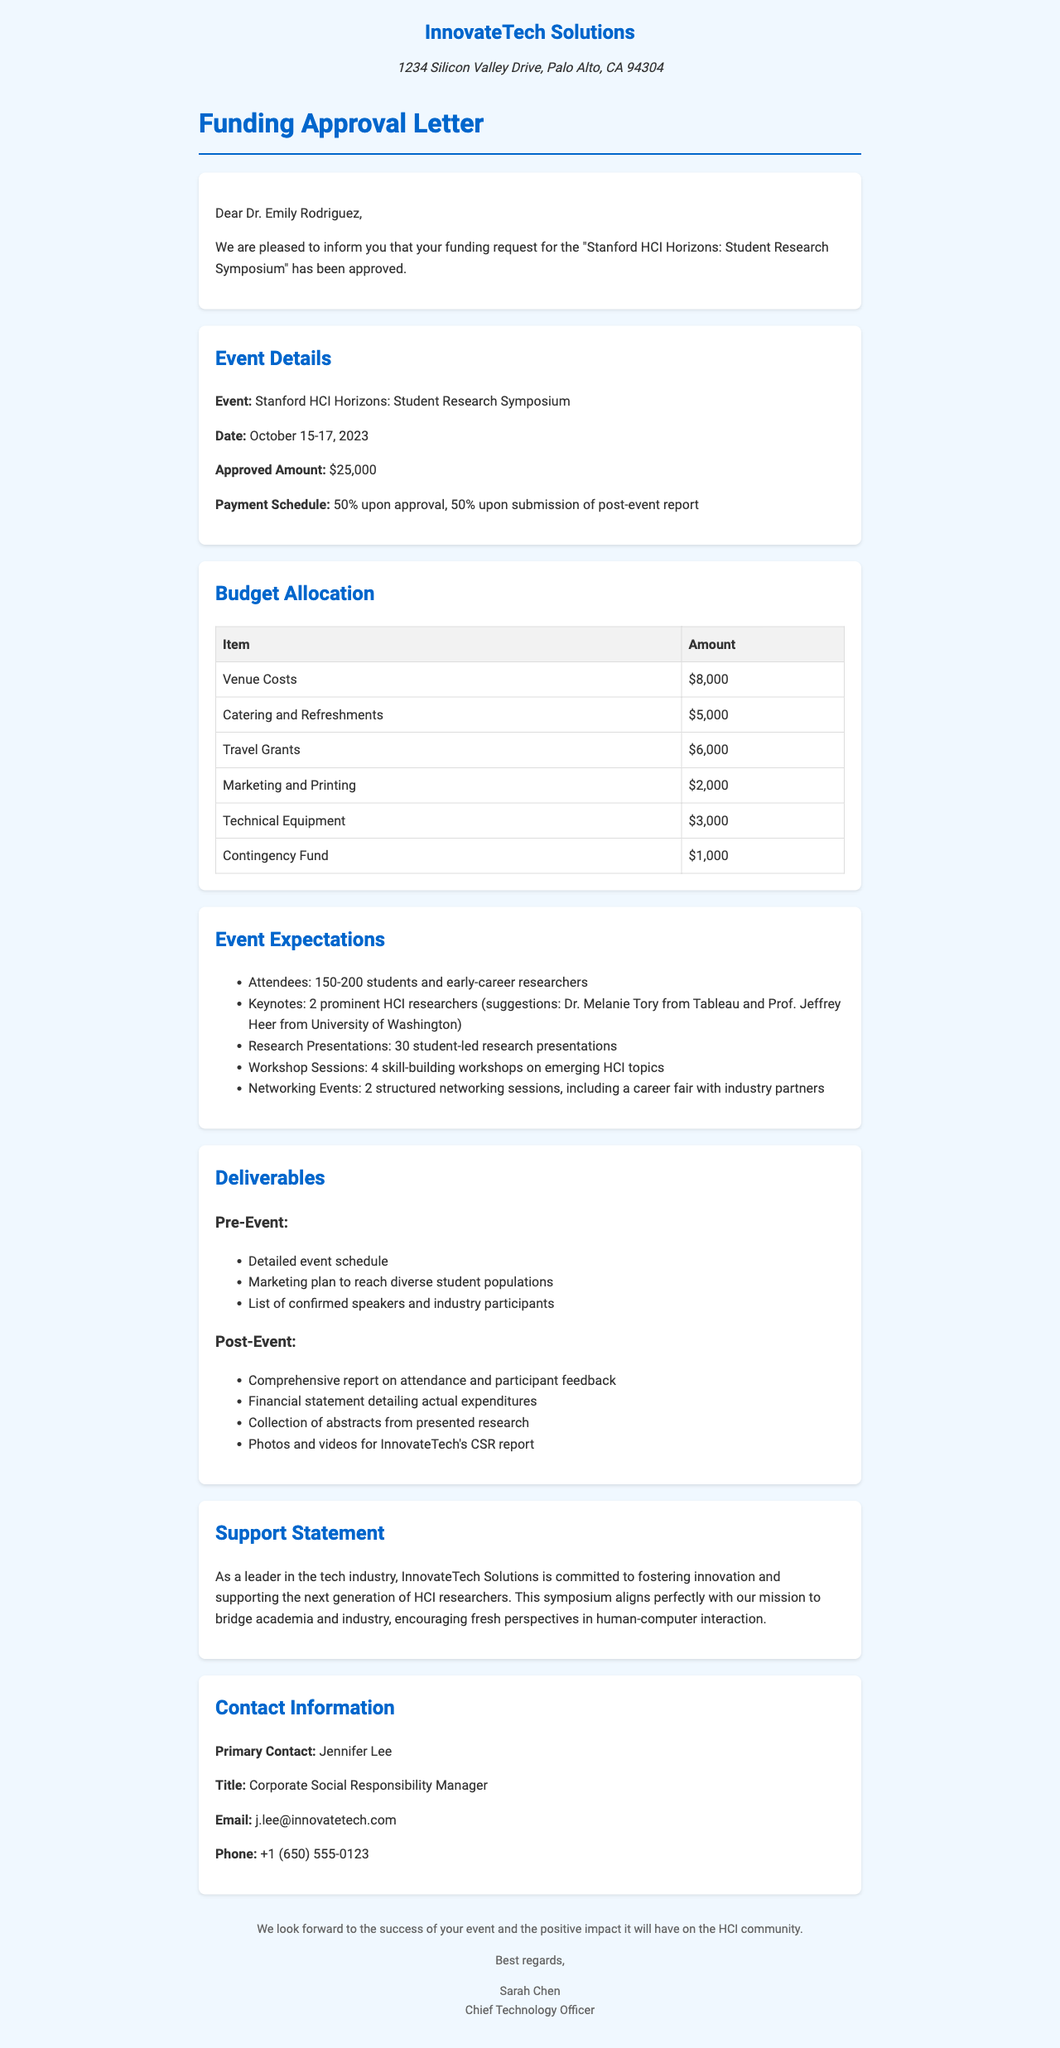What is the name of the event? The name of the event is mentioned in the funding details section of the document.
Answer: Stanford HCI Horizons: Student Research Symposium What is the approved funding amount? The document specifies the approved funding amount in the funding details section.
Answer: $25,000 When is the event scheduled to take place? The date of the event is clearly stated in the funding details section.
Answer: October 15-17, 2023 How many workshops are planned for the event? The number of workshop sessions is listed under the event expectations section.
Answer: 4 Who is the primary contact for this funding? The primary contact's name is provided in the contact information section of the document.
Answer: Jennifer Lee What is the budget allocation for catering and refreshments? The specific budget for catering and refreshments can be found in the budget allocation section.
Answer: $5,000 What type of sessions will the event include for networking? The document outlines the networking opportunities planned for the event.
Answer: 2 structured networking sessions What is the contingency fund amount? The budget allocation includes a specific amount set aside for contingencies.
Answer: $1,000 Why is InnovateTech Solutions supporting this event? The support statement in the document explains the reason for sponsorship.
Answer: Fostering innovation and supporting the next generation of HCI researchers 